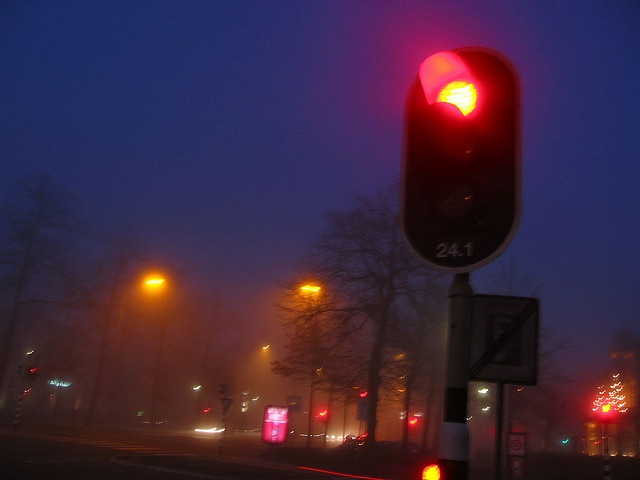Describe the objects in this image and their specific colors. I can see traffic light in navy, black, maroon, and salmon tones, traffic light in navy, black, maroon, and brown tones, traffic light in navy, brown, red, and salmon tones, traffic light in maroon, black, and navy tones, and car in navy, maroon, brown, and tan tones in this image. 